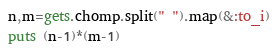<code> <loc_0><loc_0><loc_500><loc_500><_Ruby_>n,m=gets.chomp.split(" ").map(&:to_i)
puts (n-1)*(m-1)
</code> 